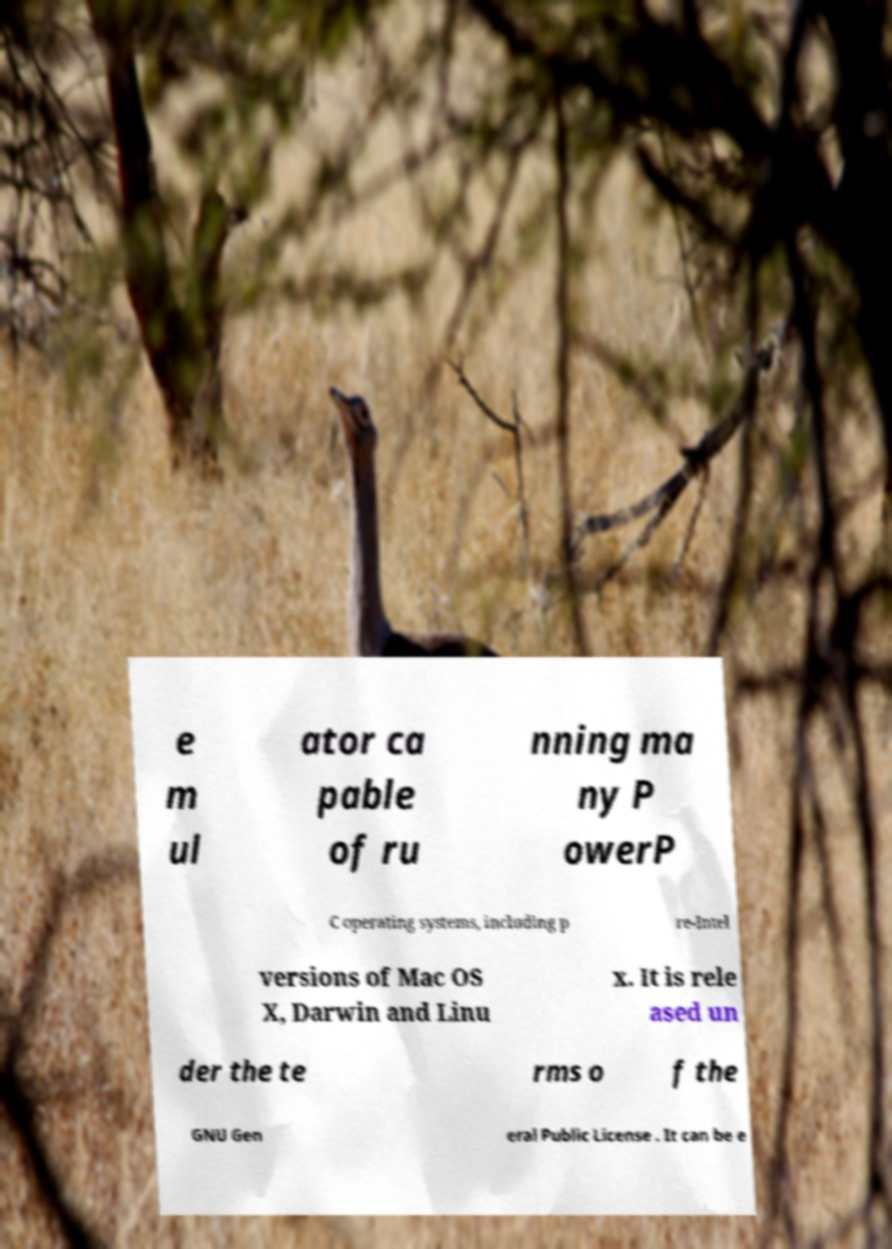There's text embedded in this image that I need extracted. Can you transcribe it verbatim? e m ul ator ca pable of ru nning ma ny P owerP C operating systems, including p re-Intel versions of Mac OS X, Darwin and Linu x. It is rele ased un der the te rms o f the GNU Gen eral Public License . It can be e 